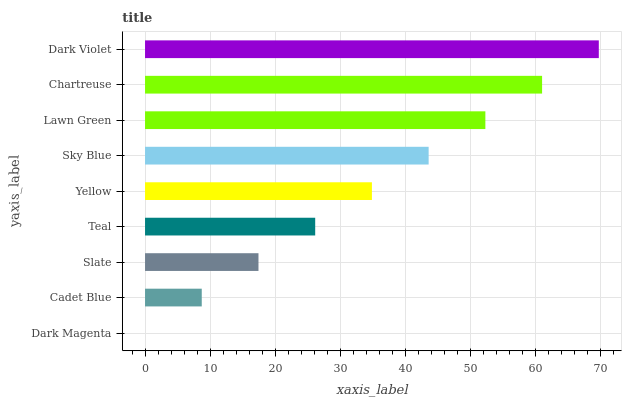Is Dark Magenta the minimum?
Answer yes or no. Yes. Is Dark Violet the maximum?
Answer yes or no. Yes. Is Cadet Blue the minimum?
Answer yes or no. No. Is Cadet Blue the maximum?
Answer yes or no. No. Is Cadet Blue greater than Dark Magenta?
Answer yes or no. Yes. Is Dark Magenta less than Cadet Blue?
Answer yes or no. Yes. Is Dark Magenta greater than Cadet Blue?
Answer yes or no. No. Is Cadet Blue less than Dark Magenta?
Answer yes or no. No. Is Yellow the high median?
Answer yes or no. Yes. Is Yellow the low median?
Answer yes or no. Yes. Is Chartreuse the high median?
Answer yes or no. No. Is Dark Magenta the low median?
Answer yes or no. No. 